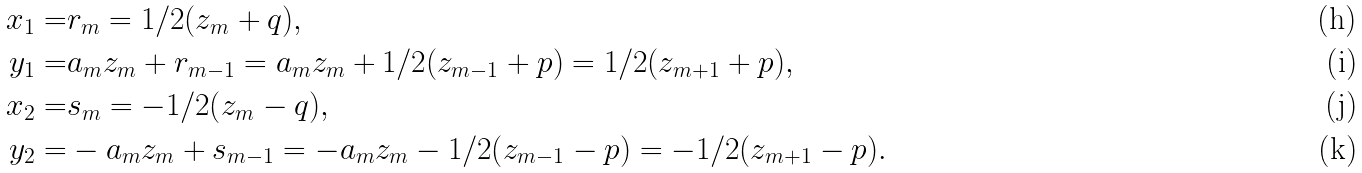<formula> <loc_0><loc_0><loc_500><loc_500>x _ { 1 } = & r _ { m } = 1 / 2 ( z _ { m } + q ) , \\ y _ { 1 } = & a _ { m } z _ { m } + r _ { m - 1 } = a _ { m } z _ { m } + 1 / 2 ( z _ { m - 1 } + p ) = 1 / 2 ( z _ { m + 1 } + p ) , \\ x _ { 2 } = & s _ { m } = - 1 / 2 ( z _ { m } - q ) , \\ y _ { 2 } = & - a _ { m } z _ { m } + s _ { m - 1 } = - a _ { m } z _ { m } - 1 / 2 ( z _ { m - 1 } - p ) = - 1 / 2 ( z _ { m + 1 } - p ) .</formula> 